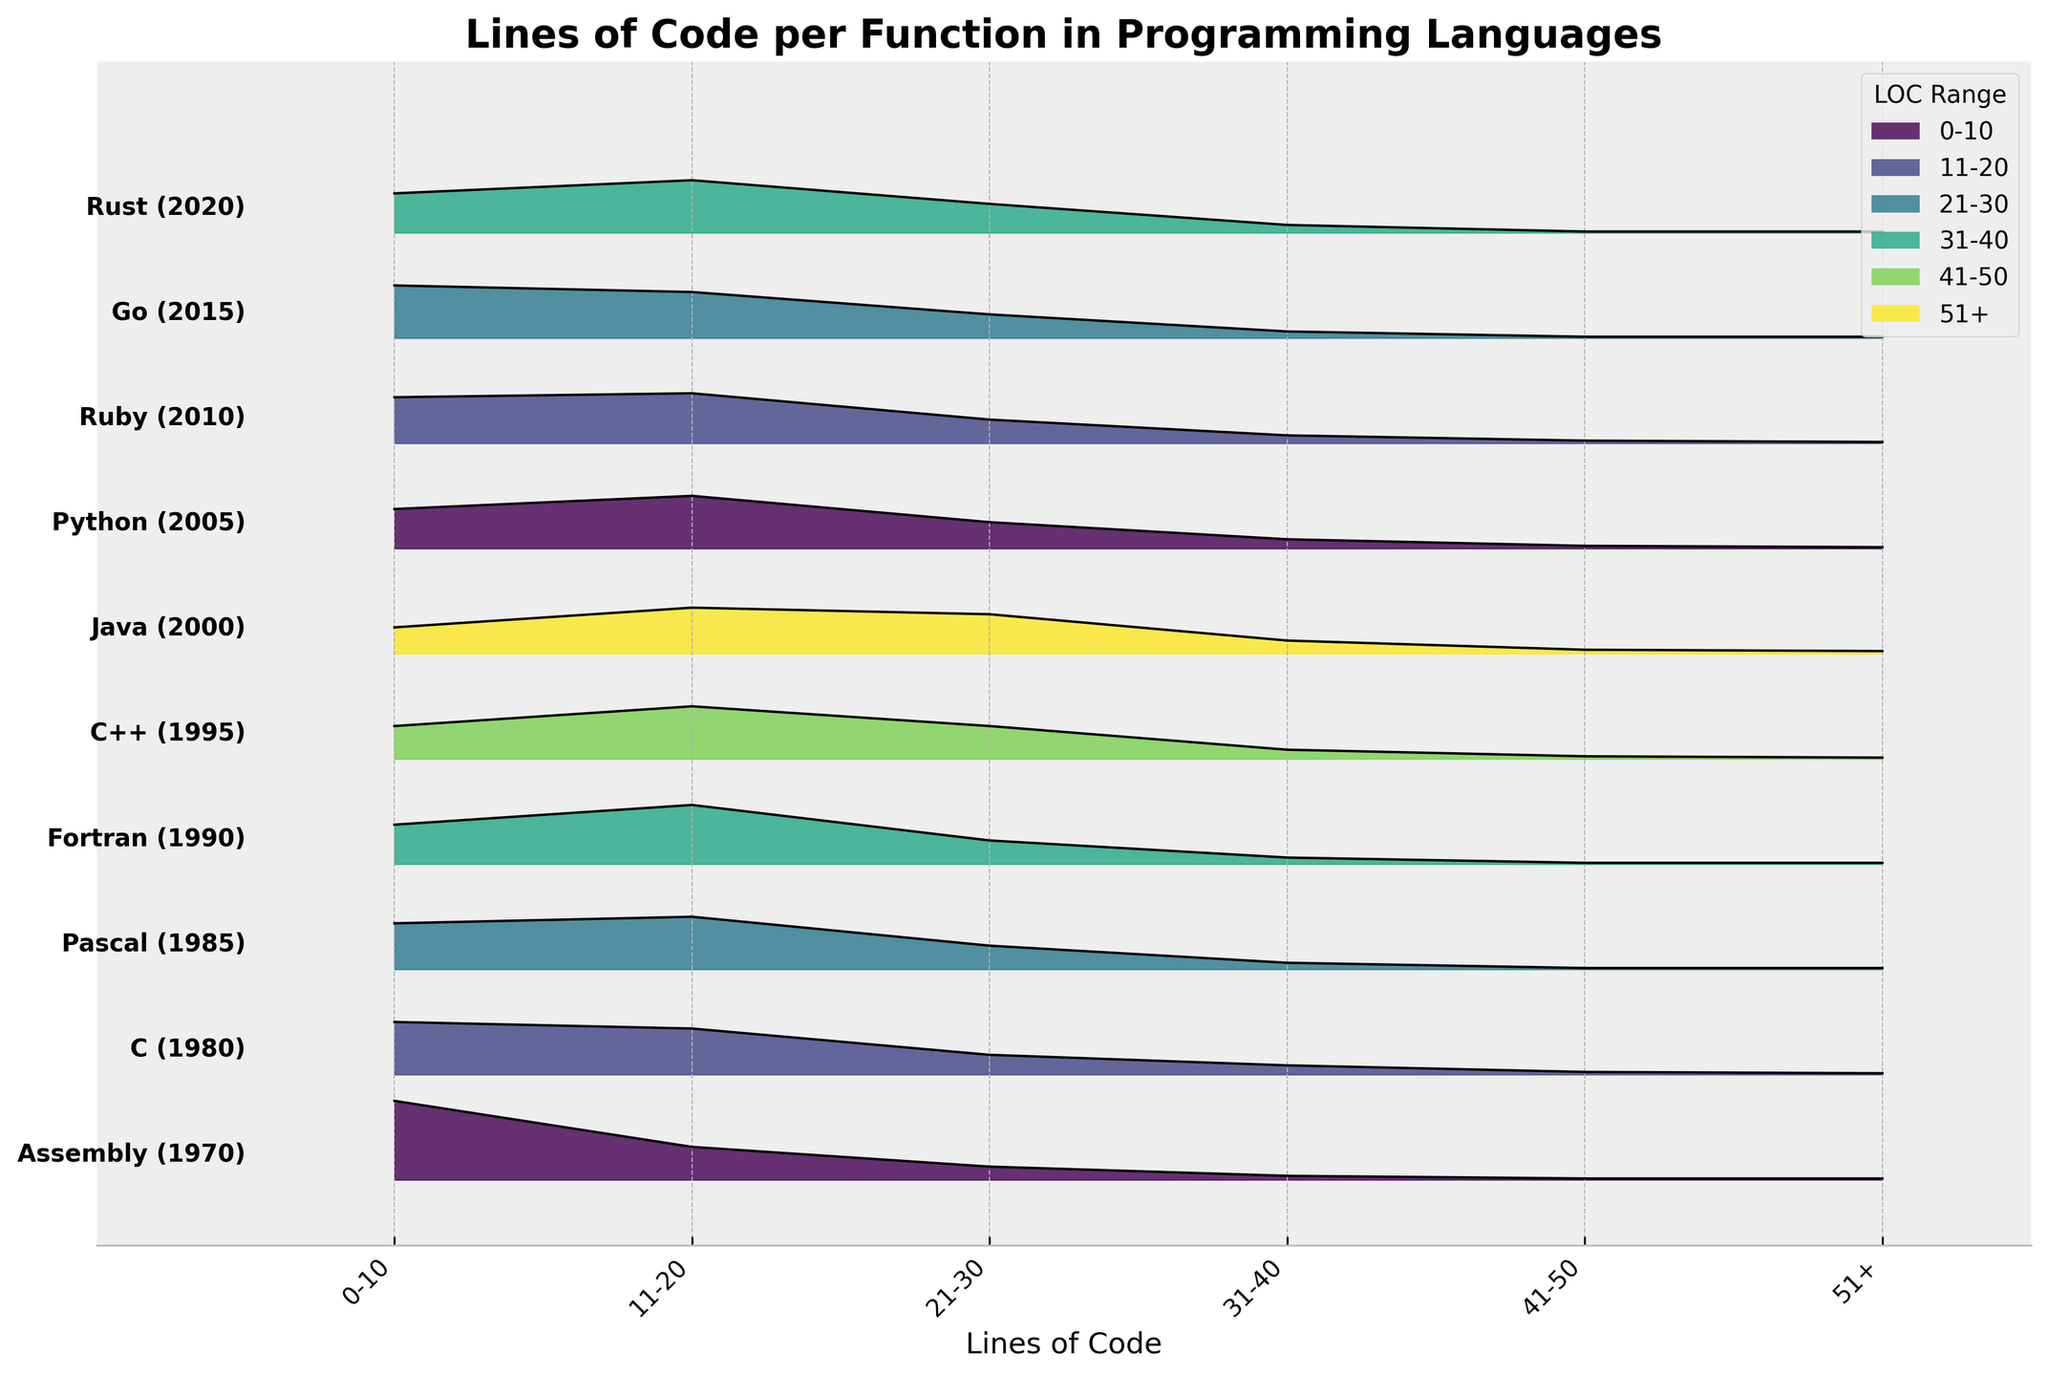What does the title of the figure say? The title of the figure appears at the top and summarizes the content being displayed. In this instance, the title is "Lines of Code per Function in Programming Languages."
Answer: Lines of Code per Function in Programming Languages How is the x-axis labeled? The x-axis label is provided beneath the horizontal axis and indicates what the axis represents. In this case, it is labeled "Lines of Code," signifying the range of lines of code per function for each language.
Answer: Lines of Code How many different programming languages are represented in the plot? Each row in the plot represents a different programming language. Counting these rows gives the total number of languages depicted.
Answer: 10 Which programming language has the highest proportion of functions with 0-10 lines of code? Look for the plot with the highest filled section in the 0-10 Lines of Code range. Assembly, with 60%, has the highest proportion.
Answer: Assembly Which two programming languages have the same percentage of functions with 51+ lines of code? Compare the percentages for 51+ lines of code across all languages. Assembly, Pascal, Fortran, Python, Ruby, Go, and Rust each have 1%. The correct pairs can be any two of these languages, since all share the same percentage.
Answer: (Multiple possible pairs, e.g., Assembly and Pascal) How have the proportions of functions with 11-20 lines of code changed from 1980 to 2020? Compare the proportions for the 11-20 lines of code range for the years 1980 (C) and 2020 (Rust). C has 35%, and Rust also has 40%.
Answer: Increased from 35% to 40% Which language in the 2000s has the highest proportion of functions with 31-40 lines of code? Look at the percentages for the group that falls within the 31-40 lines of code range for languages in the 2000s (Java, Python, and Ruby). Java with 10% has the highest.
Answer: Java What is the average proportion of functions with 21-30 lines of code across all languages? Add up the proportions for the 21-30 lines of code range for all languages and divide by the number of languages: (10 + 15 + 18 + 18 + 25 + 30 + 20 + 18 + 18 + 22) / 10 = 19.4%.
Answer: 19.4% How do the distributions of lines of code in C (1980) and Rust (2020) compare for the range 0-30 lines? Compare the percentages for the 0-10, 11-20, and 21-30 ranges for C and Rust. For C: 40% + 35% + 15% = 90%, and for Rust: 30% + 40% + 22% = 92%. Rust has a slightly higher proportion in this range.
Answer: Rust has a higher proportion 